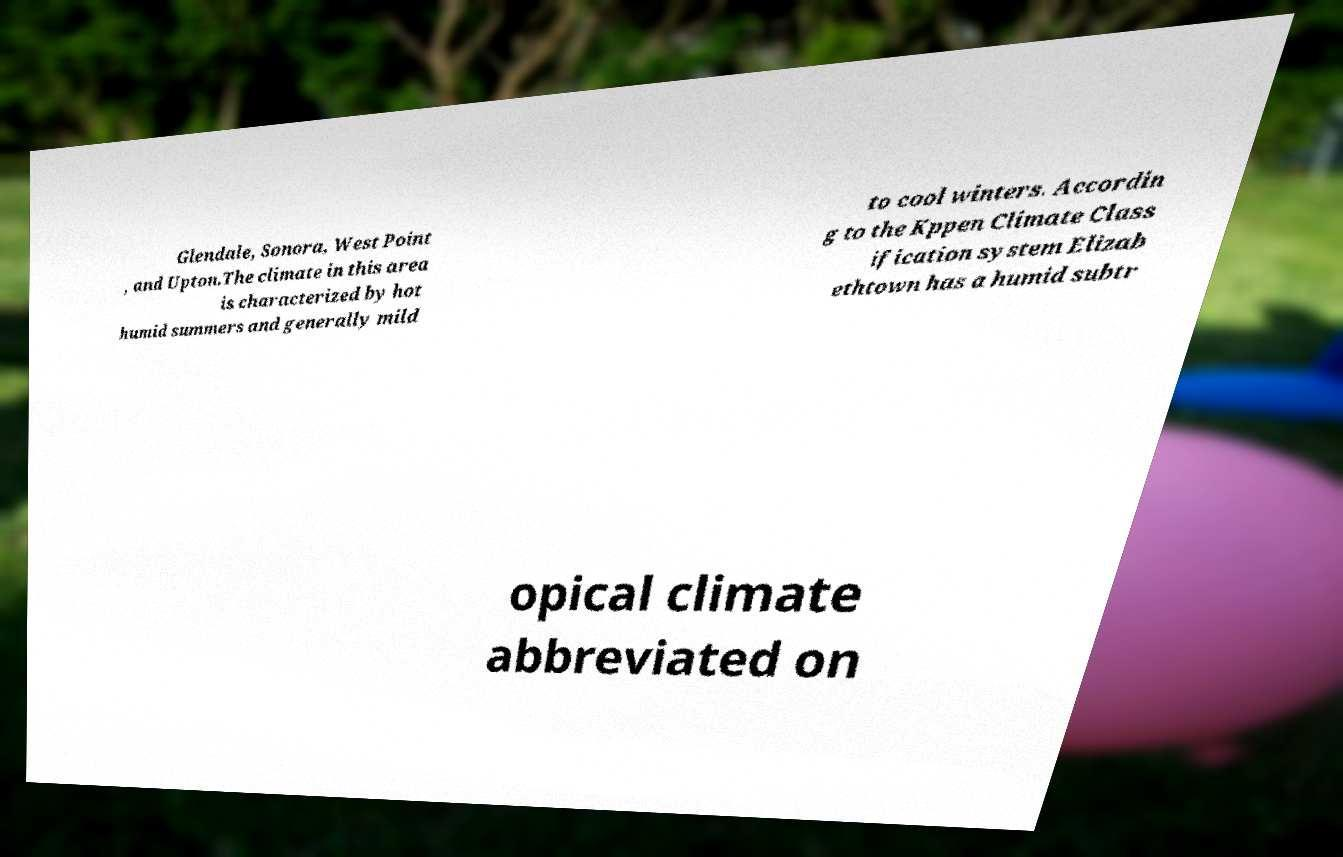I need the written content from this picture converted into text. Can you do that? Glendale, Sonora, West Point , and Upton.The climate in this area is characterized by hot humid summers and generally mild to cool winters. Accordin g to the Kppen Climate Class ification system Elizab ethtown has a humid subtr opical climate abbreviated on 